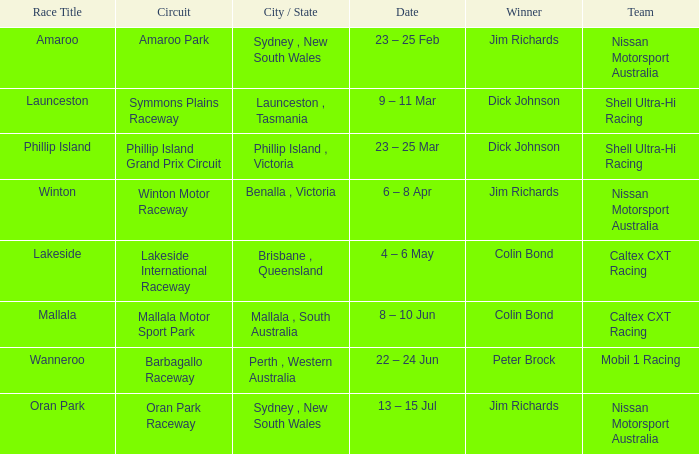On which date is the lakeside race title taking place? 4 – 6 May. 